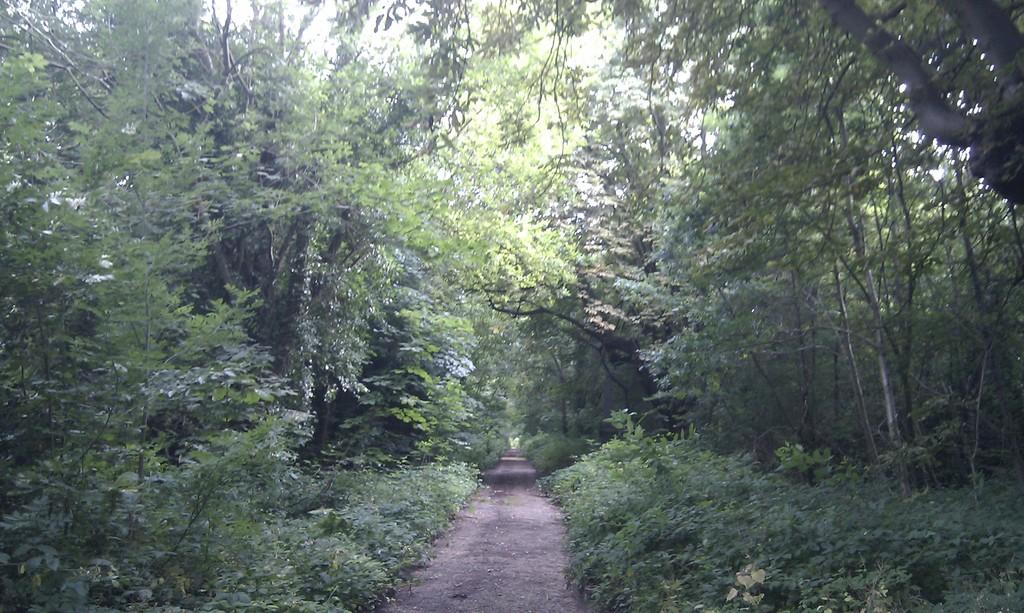What is the main feature of the image? There is a road in the image. What can be seen on the sides of the road? There are plants and trees on the sides of the road. How many pieces of coal can be seen on the road in the image? There is no coal present on the road in the image. What type of legs are visible in the image? There are no legs visible in the image. 